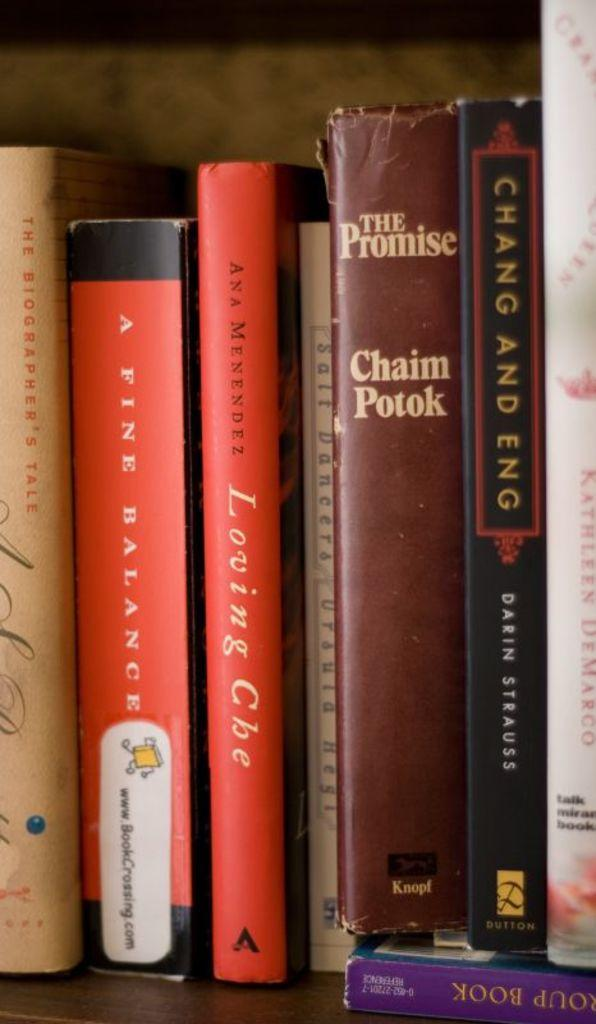<image>
Share a concise interpretation of the image provided. A collection of books on a shelf includes the title The Promise by Chaim Potok. 